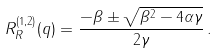Convert formula to latex. <formula><loc_0><loc_0><loc_500><loc_500>R _ { R } ^ { ( 1 , 2 ) } ( q ) = \frac { - \beta \pm \sqrt { \beta ^ { 2 } - 4 \alpha \gamma } } { 2 \gamma } \, .</formula> 